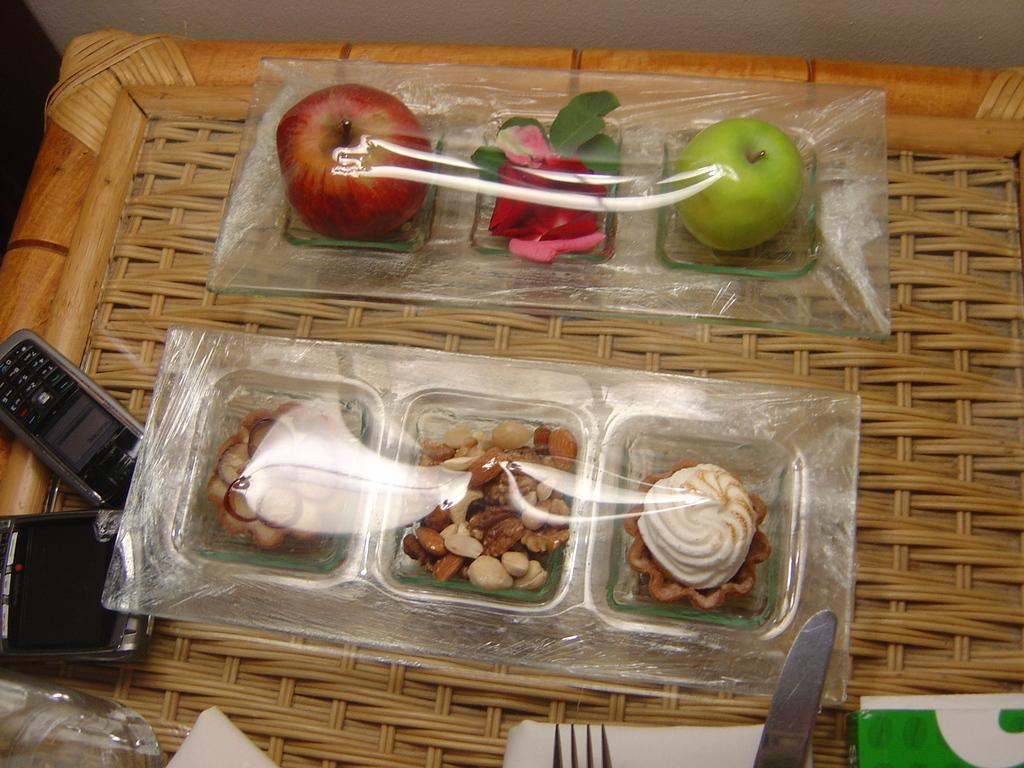What type of surface is visible in the image? There is a wooden surface in the image. What items can be seen on the wooden surface? There are mobiles, a fork, a knife, a box with dry fruits, other snacks, a box with green and red apples, and a flower on the wooden surface. How many types of fruits are present on the wooden surface? There are two types of fruits, green apples and red apples, present on the wooden surface. What might be used for cutting or slicing the fruits on the wooden surface? The knife on the wooden surface might be used for cutting or slicing the fruits. What type of punishment is being given to the worm in the image? There is no worm present in the image, so no punishment is being given. What type of fan is visible in the image? There is no fan present in the image. 